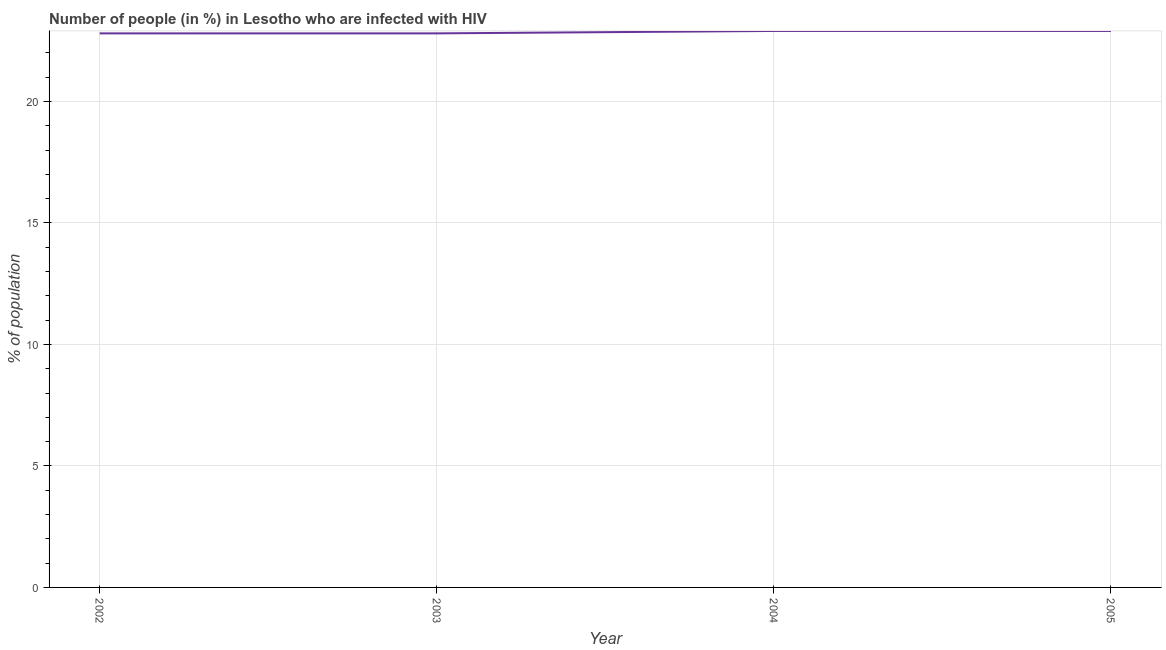What is the number of people infected with hiv in 2002?
Keep it short and to the point. 22.8. Across all years, what is the maximum number of people infected with hiv?
Offer a very short reply. 22.9. Across all years, what is the minimum number of people infected with hiv?
Provide a short and direct response. 22.8. In which year was the number of people infected with hiv minimum?
Offer a very short reply. 2002. What is the sum of the number of people infected with hiv?
Your response must be concise. 91.4. What is the difference between the number of people infected with hiv in 2003 and 2005?
Offer a terse response. -0.1. What is the average number of people infected with hiv per year?
Offer a very short reply. 22.85. What is the median number of people infected with hiv?
Give a very brief answer. 22.85. In how many years, is the number of people infected with hiv greater than 16 %?
Offer a very short reply. 4. What is the ratio of the number of people infected with hiv in 2003 to that in 2005?
Provide a succinct answer. 1. Is the number of people infected with hiv in 2003 less than that in 2004?
Your answer should be compact. Yes. Is the difference between the number of people infected with hiv in 2002 and 2005 greater than the difference between any two years?
Keep it short and to the point. Yes. What is the difference between the highest and the second highest number of people infected with hiv?
Give a very brief answer. 0. Is the sum of the number of people infected with hiv in 2002 and 2005 greater than the maximum number of people infected with hiv across all years?
Make the answer very short. Yes. What is the difference between the highest and the lowest number of people infected with hiv?
Provide a short and direct response. 0.1. In how many years, is the number of people infected with hiv greater than the average number of people infected with hiv taken over all years?
Give a very brief answer. 2. What is the difference between two consecutive major ticks on the Y-axis?
Ensure brevity in your answer.  5. What is the title of the graph?
Provide a succinct answer. Number of people (in %) in Lesotho who are infected with HIV. What is the label or title of the Y-axis?
Ensure brevity in your answer.  % of population. What is the % of population of 2002?
Your answer should be compact. 22.8. What is the % of population in 2003?
Keep it short and to the point. 22.8. What is the % of population of 2004?
Ensure brevity in your answer.  22.9. What is the % of population of 2005?
Offer a very short reply. 22.9. What is the difference between the % of population in 2003 and 2004?
Keep it short and to the point. -0.1. What is the difference between the % of population in 2003 and 2005?
Offer a terse response. -0.1. What is the ratio of the % of population in 2002 to that in 2003?
Your answer should be very brief. 1. What is the ratio of the % of population in 2002 to that in 2005?
Your answer should be very brief. 1. What is the ratio of the % of population in 2004 to that in 2005?
Your answer should be very brief. 1. 